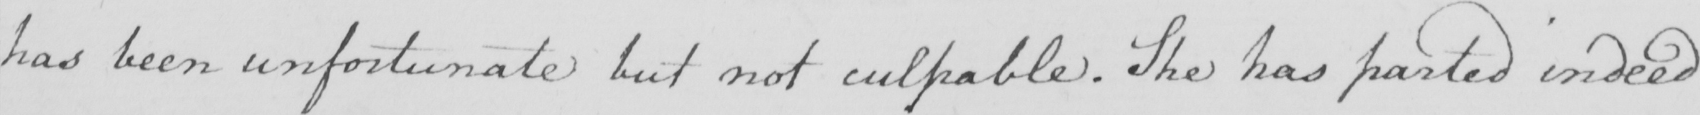What is written in this line of handwriting? has been unfortunate but not culpable . She has parted indeed 